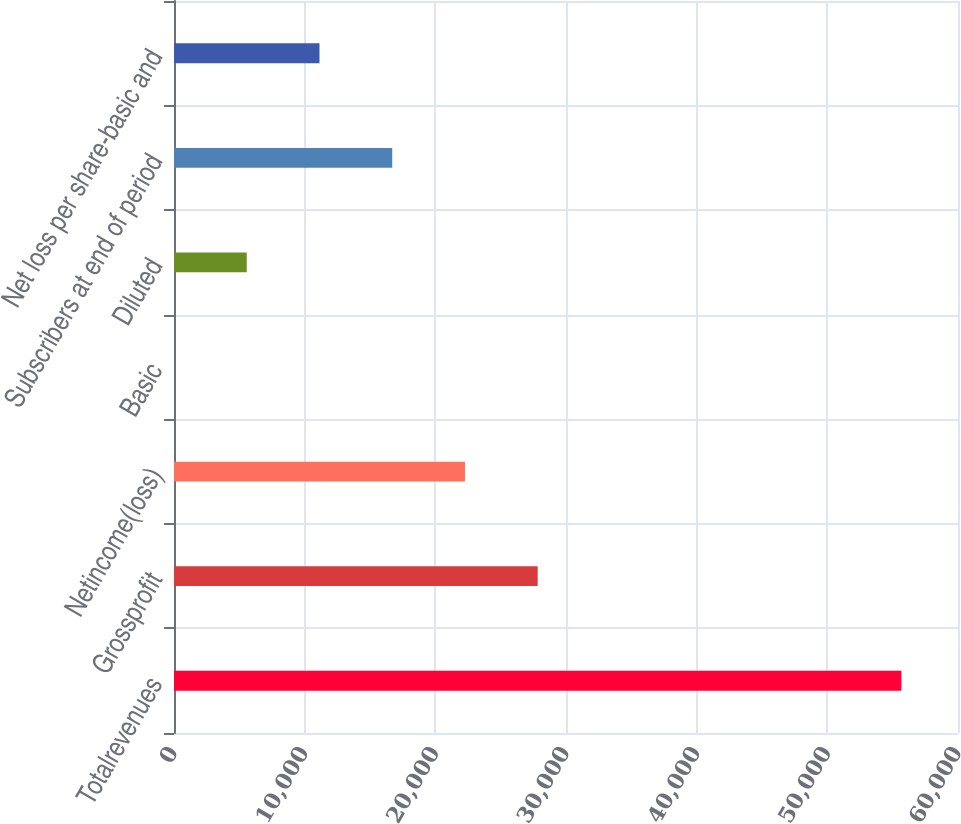Convert chart. <chart><loc_0><loc_0><loc_500><loc_500><bar_chart><fcel>Totalrevenues<fcel>Grossprofit<fcel>Netincome(loss)<fcel>Basic<fcel>Diluted<fcel>Subscribers at end of period<fcel>Net loss per share-basic and<nl><fcel>55669<fcel>27834.5<fcel>22267.7<fcel>0.05<fcel>5566.95<fcel>16700.8<fcel>11133.9<nl></chart> 